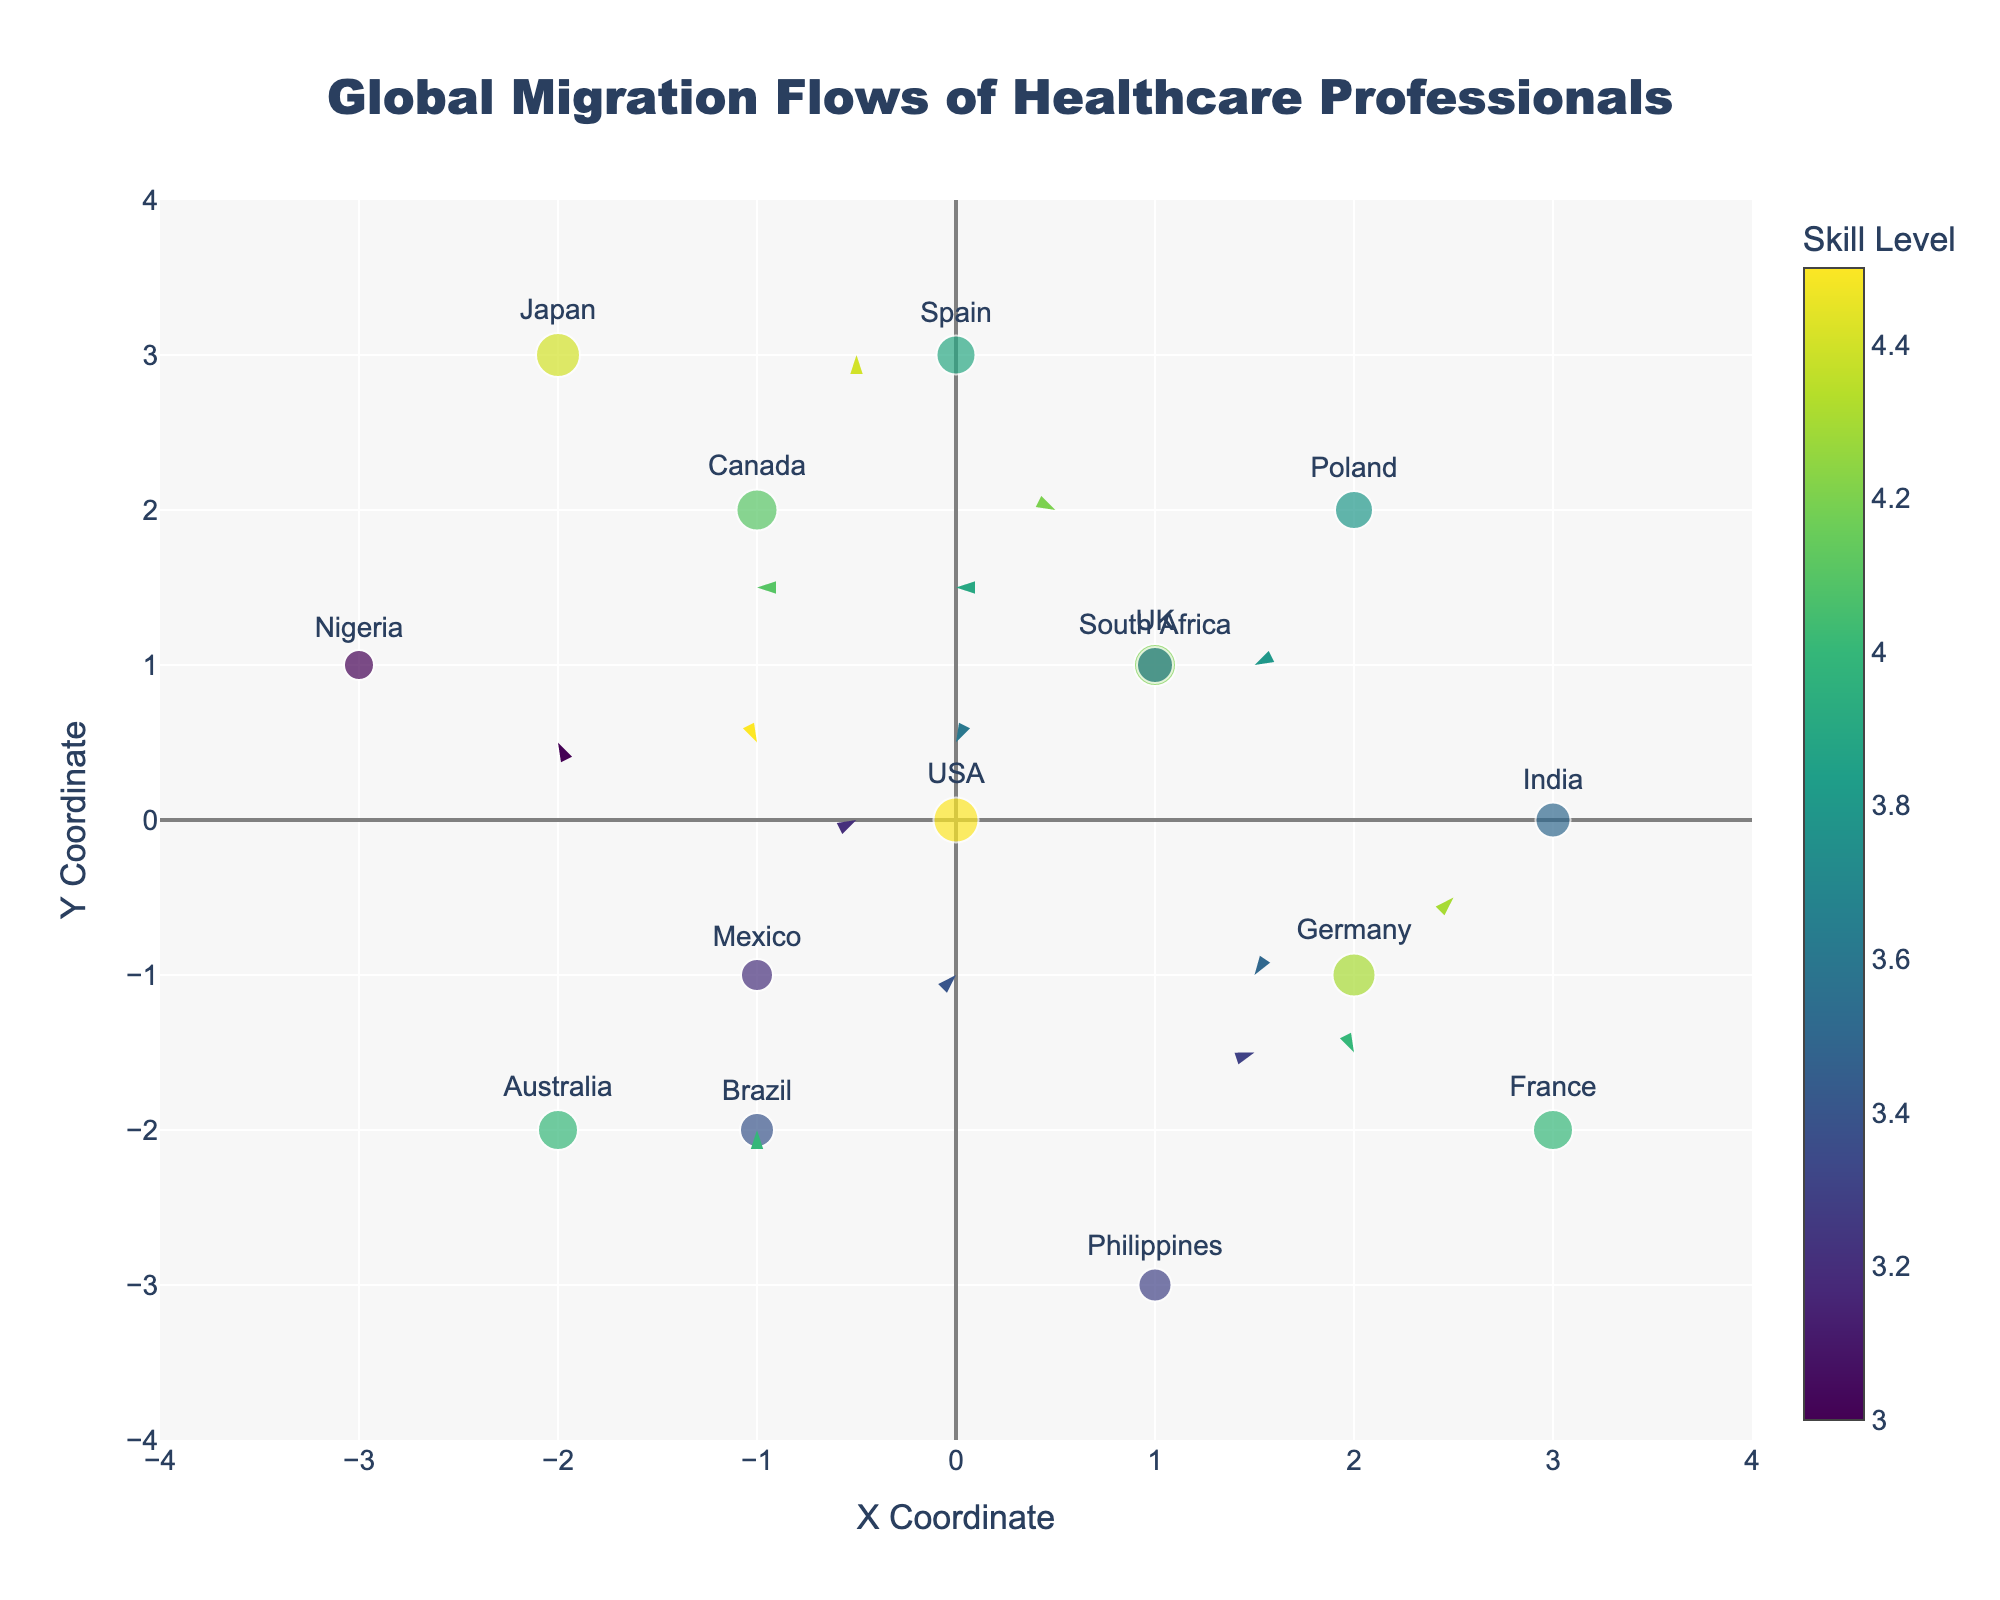What is the title of the figure? The title of the figure can be found at the top center of the plot. It reads "Global Migration Flows of Healthcare Professionals".
Answer: Global Migration Flows of Healthcare Professionals Which country has the highest skill level among healthcare professionals? The size and color of the markers represent the skill level of healthcare professionals, and the color bar provides the scale. By looking at the largest and darkest colored markers, Japan has the highest skill level of 4.4.
Answer: Japan How many countries have a skill level of more than 4.0? By examining the color and size of the markers and comparing them to the color bar, we can identify the countries with a skill level greater than 4.0: USA, UK, Germany, France, and Japan. There are five such countries.
Answer: 5 What is the direction of migration flow for healthcare professionals from the Philippines? The direction of migration flow is indicated by the arrows starting from the country's location. For the Philippines, the arrow points from (1, -3) to (2, 0). So, the direction is towards the right and upwards.
Answer: Towards right and upwards Which country is experiencing an inflow of healthcare professionals from Germany? The arrow originating from Germany points towards the country location’s end. Tracing the arrow from (2, -1), it points towards (3, 0), indicating an inflow to Japan.
Answer: Japan Among countries with skill levels lower than 4.0, which has the largest movement vector (magnitude of U and V)? We need to look at the arrows' lengths for countries with skill levels lower than 4.0: India, Philippines, Nigeria, Mexico, Poland, South Africa, and Brazil. Calculating the magnitude for each, India has the largest movement vector with a magnitude √((-3)^2 + (-2)^2) = √(13) ≈ 3.6.
Answer: India What is the average skill level of healthcare professionals across all countries? Sum all the skill levels: 4.5 + 4.2 + 4.3 + 4.1 + 4.0 + 3.5 + 3.3 + 3.0 + 3.2 + 3.8 + 3.9 + 4.0 + 4.4 + 3.6 + 3.4 = 57.2. Divide by the number of countries: 57.2 / 15 ≈ 3.81.
Answer: 3.81 Which country has the smallest marker on the plot and what is its skill level? The marker size corresponds to the skill level. Nigeria has the smallest marker and its skill level is 3.0, as indicated by the smallest size and light color.
Answer: Nigeria, 3.0 Do any countries have the same X and Y coordinates? Examining the (X, Y) coordinates for each country, no two countries share the same X and Y values.
Answer: No How many arrows indicate movements closer to the origin (0,0)? To identify, check whether the tip of the arrow brings the country closer to (0,0). For USA (-2, 1) to (-1, 0.5), UK (0.5, 2), Canada (-1, 1.5), Australia (0, -2), Nigeria (-2, 0.5), Mexico (0, 1), Brazil (1, 0). There are seven such arrows.
Answer: 7 